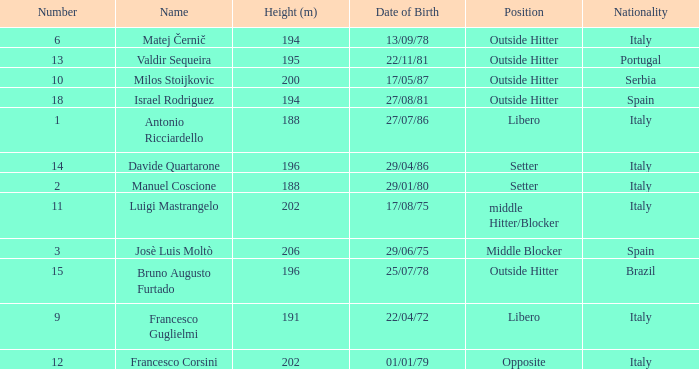Name the nationality for francesco guglielmi Italy. 